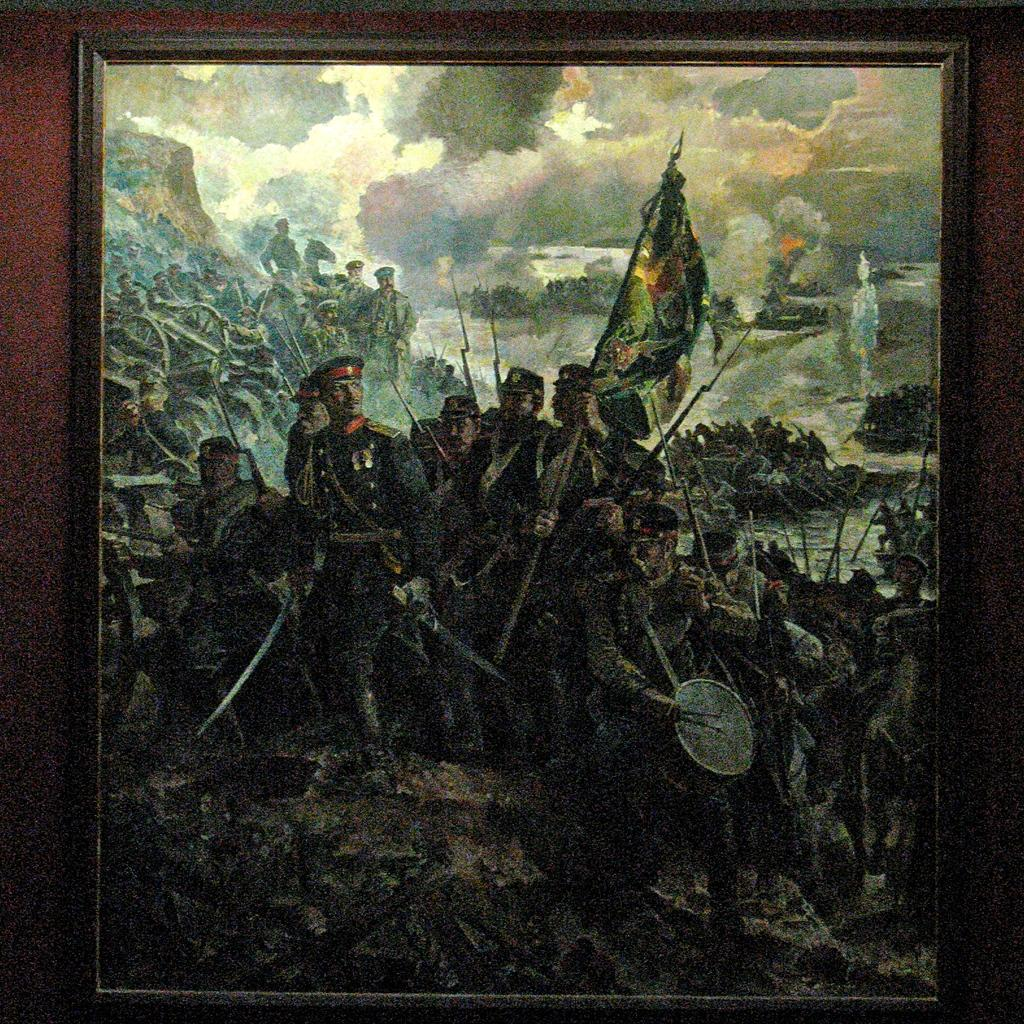What object is present in the image that typically holds a photograph? There is a photo frame in the image. Who or what can be seen in the photo frame? There are people in the photo frame. What other object is visible in the image? There is a flag in the image. What can be seen in the background of the image? There are clouds in the background of the image. What color is the surface on which the photo frame is placed? The photo frame is on a maroon color surface. How many trains can be seen passing by the dock in the image? There are no trains or docks present in the image. 